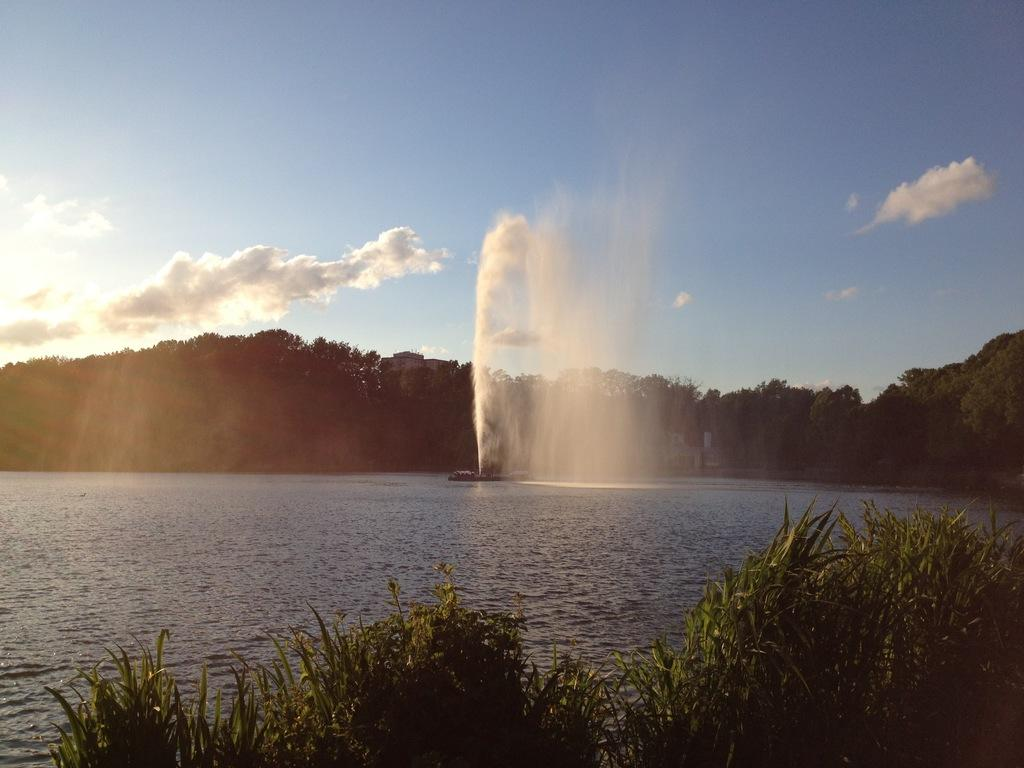What is located in the foreground of the picture? There are plants in the foreground of the picture. What is the main feature in the center of the picture? There is a water body in the center of the picture. What is happening with the water in the image? Water is spilling outside the water body. What can be seen in the background of the picture? There are trees and the sky visible in the background of the picture. What type of industry can be seen in the background of the image? There is no industry present in the image; it features plants, a water body, trees, and the sky. What musical instrument is being played by the water in the image? There is no musical instrument present in the image; water is simply spilling outside the water body. 